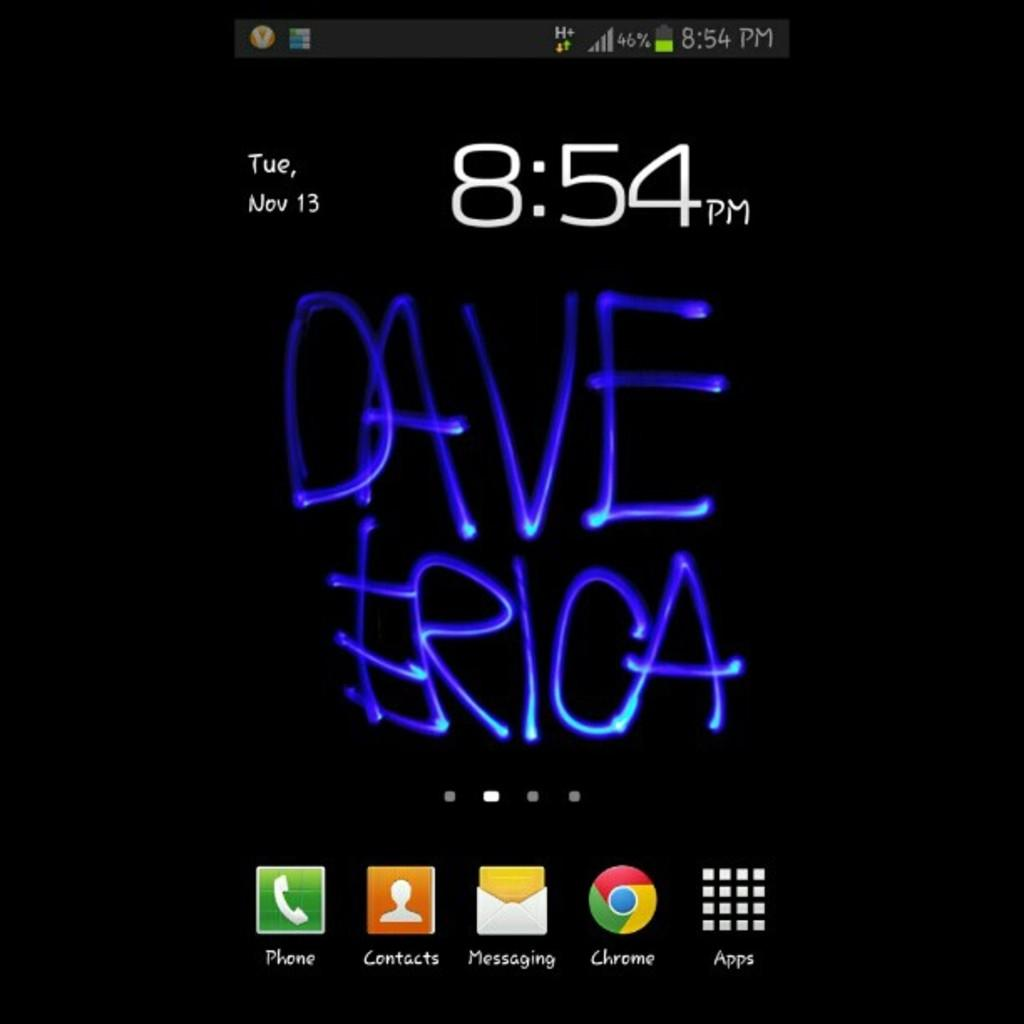<image>
Create a compact narrative representing the image presented. a phone screen that says 'dave erica' on it 